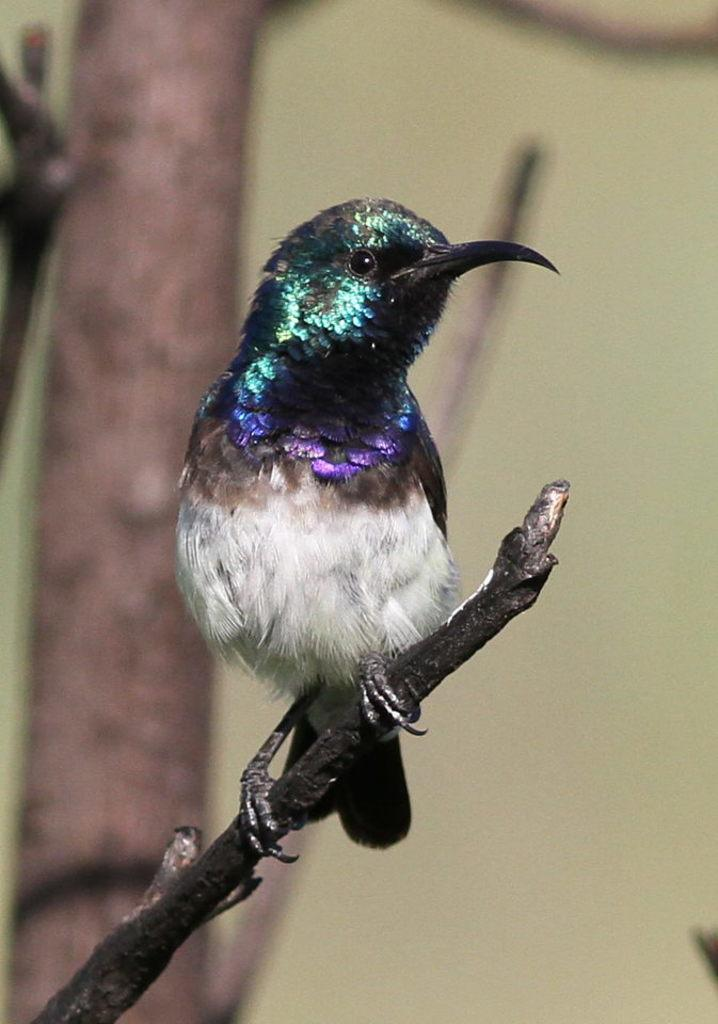What type of animal can be seen in the image? There is a bird in the image. Where is the bird located? The bird is sitting on a stem. What can be seen in the background of the image? There is a tree in the background of the image. What type of plough is the bird using to till the soil in the image? There is no plough present in the image, and the bird is not engaged in any agricultural activity. 